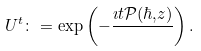Convert formula to latex. <formula><loc_0><loc_0><loc_500><loc_500>\ U _ { } ^ { t } \colon = \exp \left ( - \frac { \imath t \mathcal { P } ( \hbar { , } z ) } { } \right ) .</formula> 